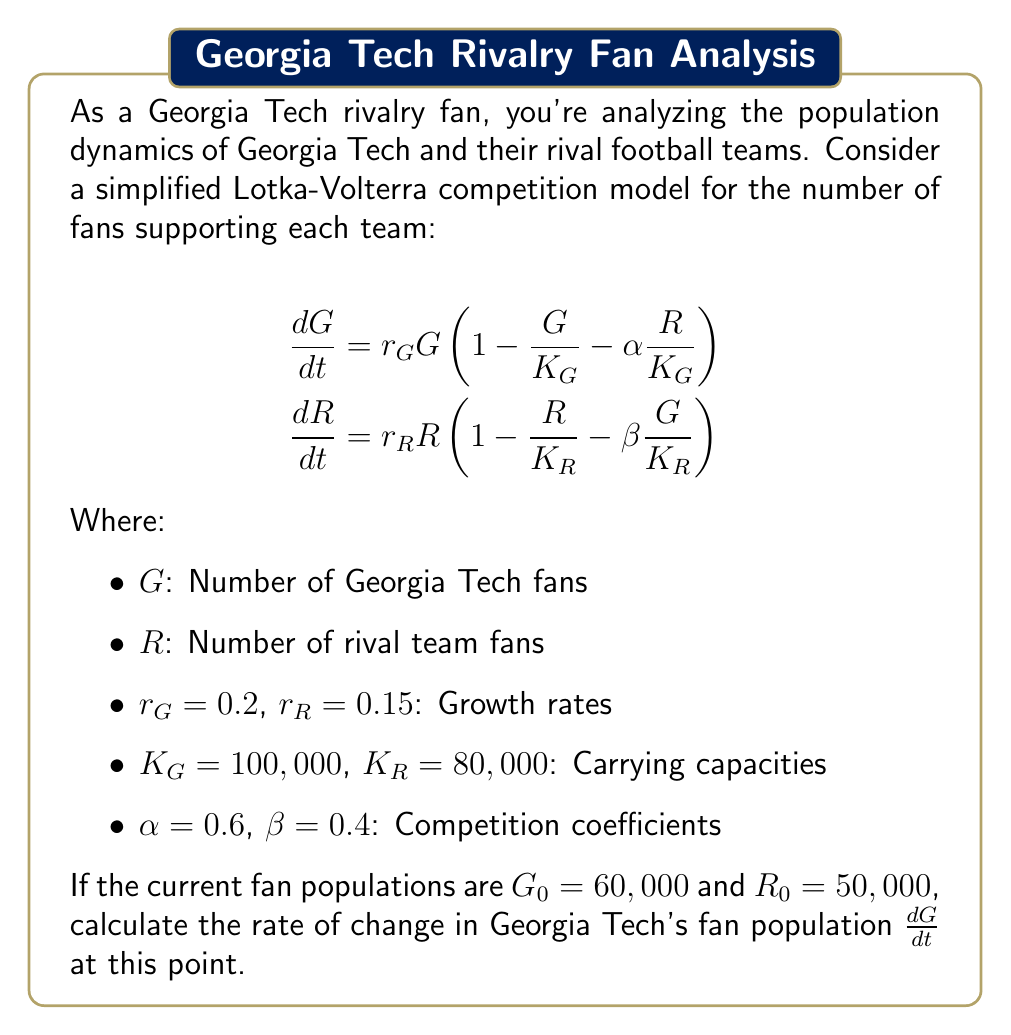Could you help me with this problem? To solve this problem, we need to use the given Lotka-Volterra competition model equation for Georgia Tech fans and plug in the known values. Let's follow these steps:

1) The equation for the rate of change in Georgia Tech's fan population is:

   $$\frac{dG}{dt} = r_G G \left(1 - \frac{G}{K_G} - \alpha \frac{R}{K_G}\right)$$

2) We're given the following values:
   $r_G = 0.2$
   $K_G = 100,000$
   $\alpha = 0.6$
   $G_0 = 60,000$
   $R_0 = 50,000$

3) Let's substitute these values into the equation:

   $$\frac{dG}{dt} = 0.2 \cdot 60,000 \left(1 - \frac{60,000}{100,000} - 0.6 \cdot \frac{50,000}{100,000}\right)$$

4) Simplify the terms inside the parentheses:
   
   $$\frac{dG}{dt} = 12,000 \left(1 - 0.6 - 0.3\right)$$

5) Calculate:
   
   $$\frac{dG}{dt} = 12,000 \cdot (0.1) = 1,200$$

Therefore, at the given point, Georgia Tech's fan population is increasing at a rate of 1,200 fans per time unit.
Answer: 1,200 fans per time unit 